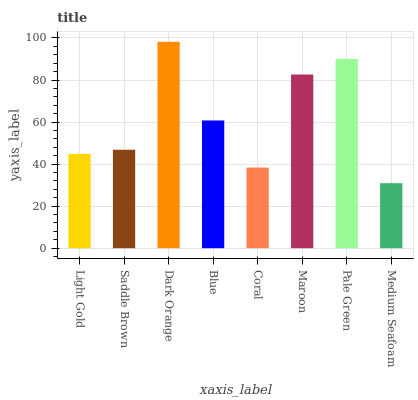Is Medium Seafoam the minimum?
Answer yes or no. Yes. Is Dark Orange the maximum?
Answer yes or no. Yes. Is Saddle Brown the minimum?
Answer yes or no. No. Is Saddle Brown the maximum?
Answer yes or no. No. Is Saddle Brown greater than Light Gold?
Answer yes or no. Yes. Is Light Gold less than Saddle Brown?
Answer yes or no. Yes. Is Light Gold greater than Saddle Brown?
Answer yes or no. No. Is Saddle Brown less than Light Gold?
Answer yes or no. No. Is Blue the high median?
Answer yes or no. Yes. Is Saddle Brown the low median?
Answer yes or no. Yes. Is Light Gold the high median?
Answer yes or no. No. Is Light Gold the low median?
Answer yes or no. No. 